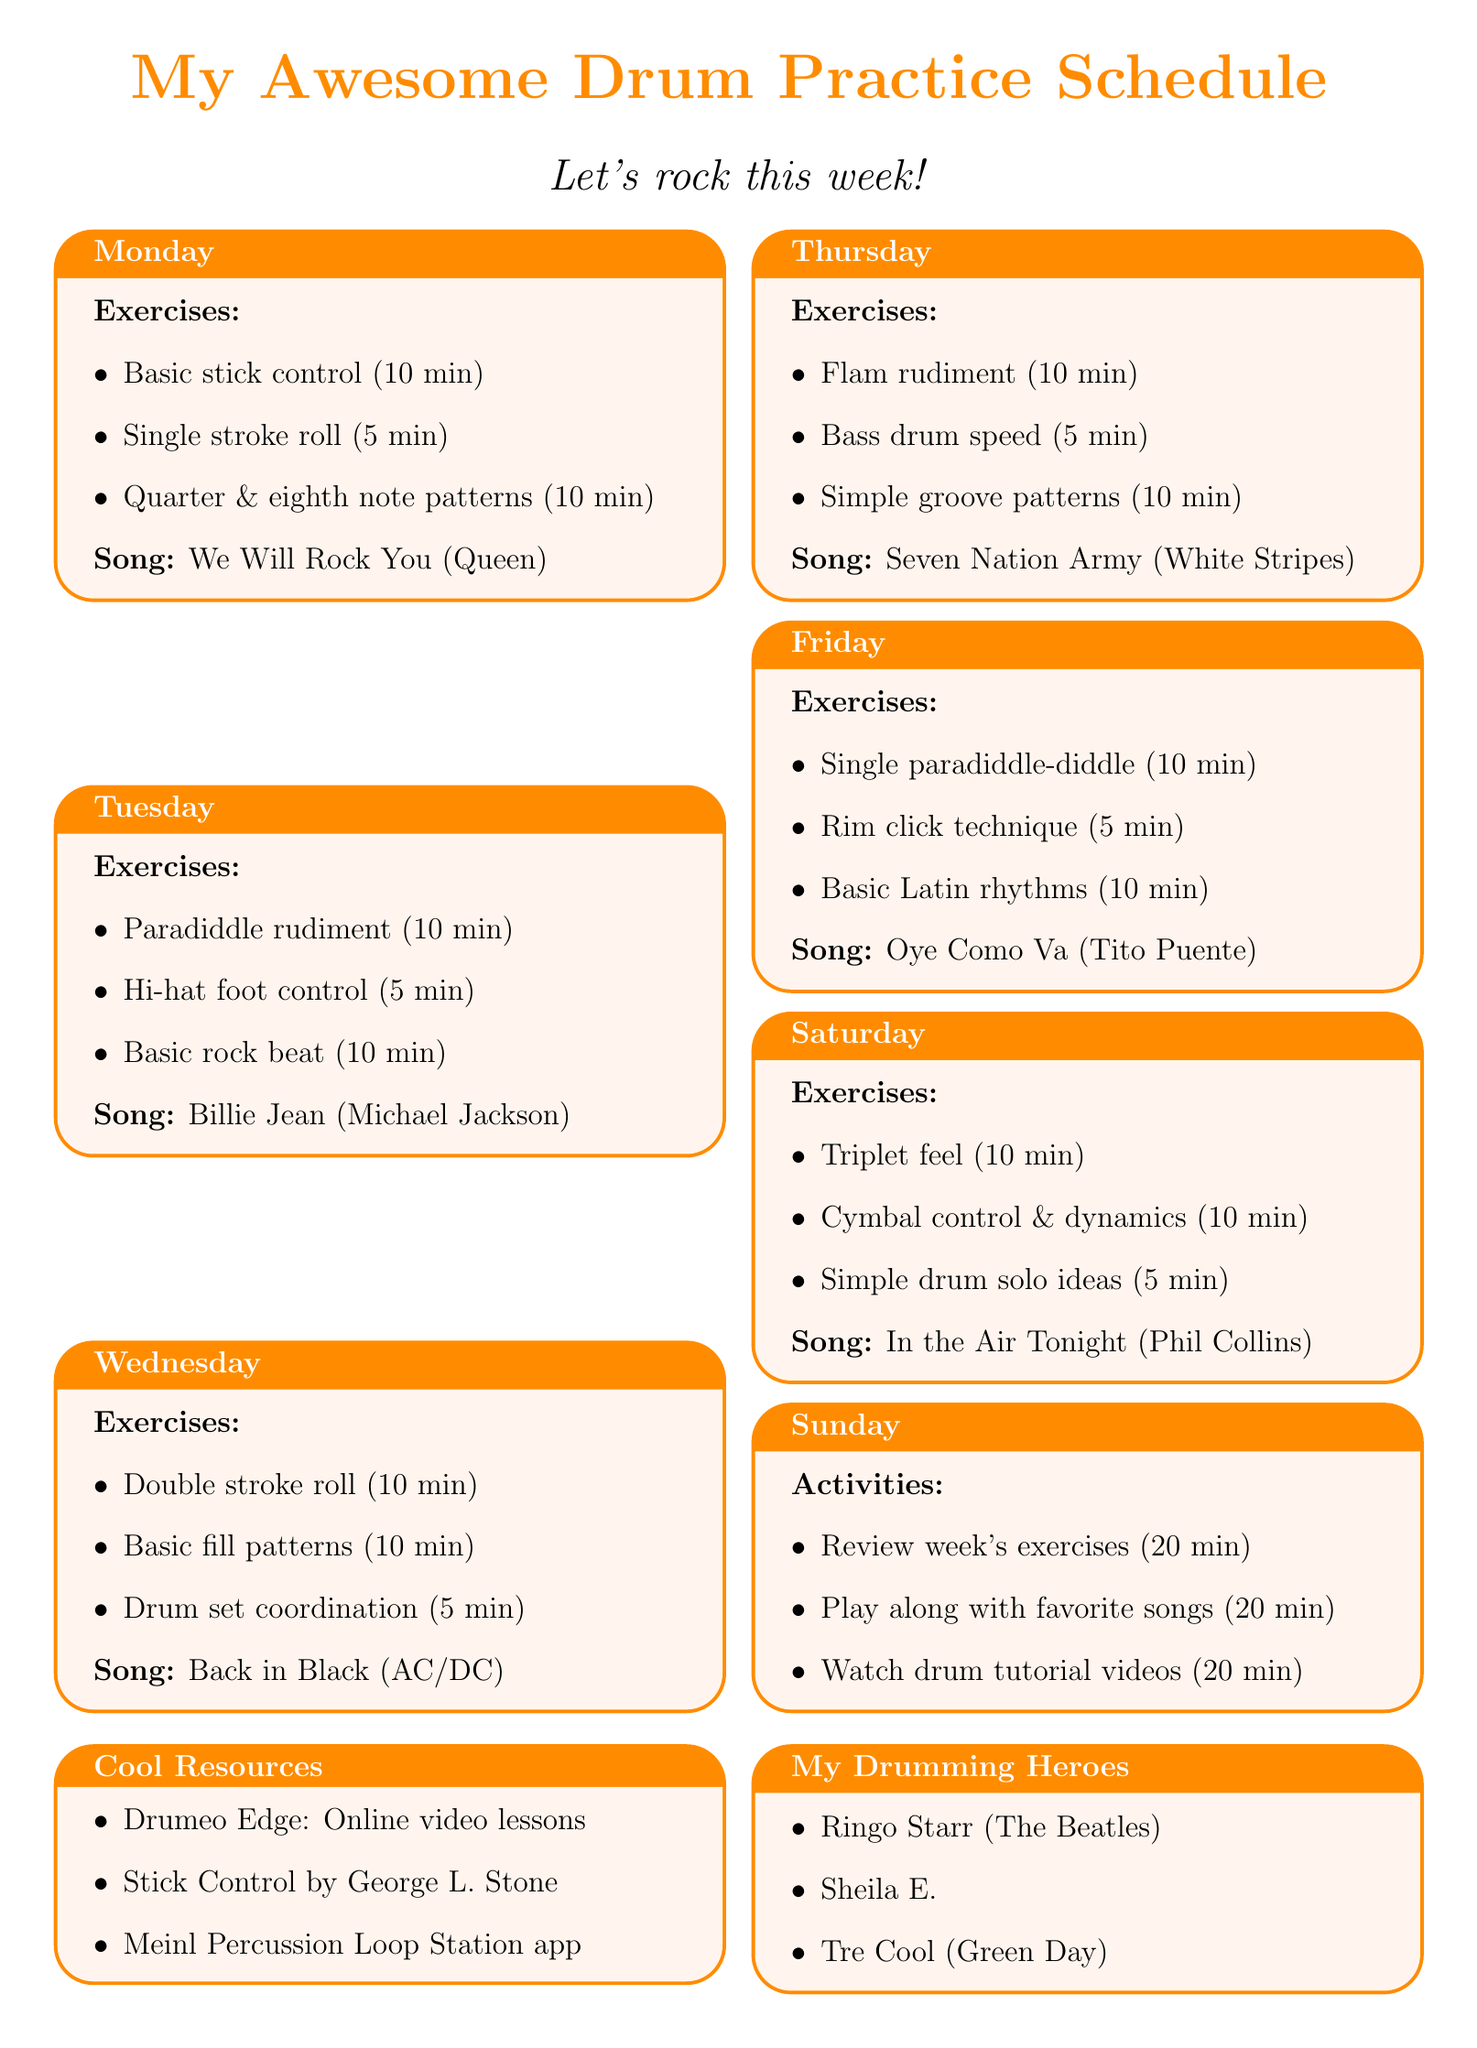What are the exercises for Monday? The exercises for Monday are listed under that day in the schedule, including stick control and roll practice.
Answer: Basic stick control, single stroke roll practice, quarter note and eighth note patterns Which song is scheduled for Tuesday? The song for Tuesday is mentioned in the specific section for that day.
Answer: Billie Jean by Michael Jackson How long should I practice on Sunday? The document states the activities for Sunday and their durations, which add up to a total time.
Answer: 60 minutes What is the main focus of Friday's exercises? The exercises for Friday include specific techniques, including single paradiddle-diddle and rim click.
Answer: Single paradiddle-diddle practice Which drummer is listed as an inspirational figure? The document provides a list of inspirational drummers, and one of them is mentioned explicitly.
Answer: Ringo Starr How many exercises are listed for Saturday? The number of exercises for Saturday is calculated based on the items listed for that day.
Answer: 3 exercises What is suggested for Sunday activities? The activities on Sunday are specifically listed in the document and highlight important review and playtime.
Answer: Review week's exercises, play along with favorite songs, watch drum tutorial videos What is one important practice tip? The practice tips section gives specific advice, and one example is highlighted in the document.
Answer: Always use a metronome during exercises What type of resource is "Drumeo Edge"? The resources listed include different types, and "Drumeo Edge" is categorized specifically.
Answer: Online learning platform 